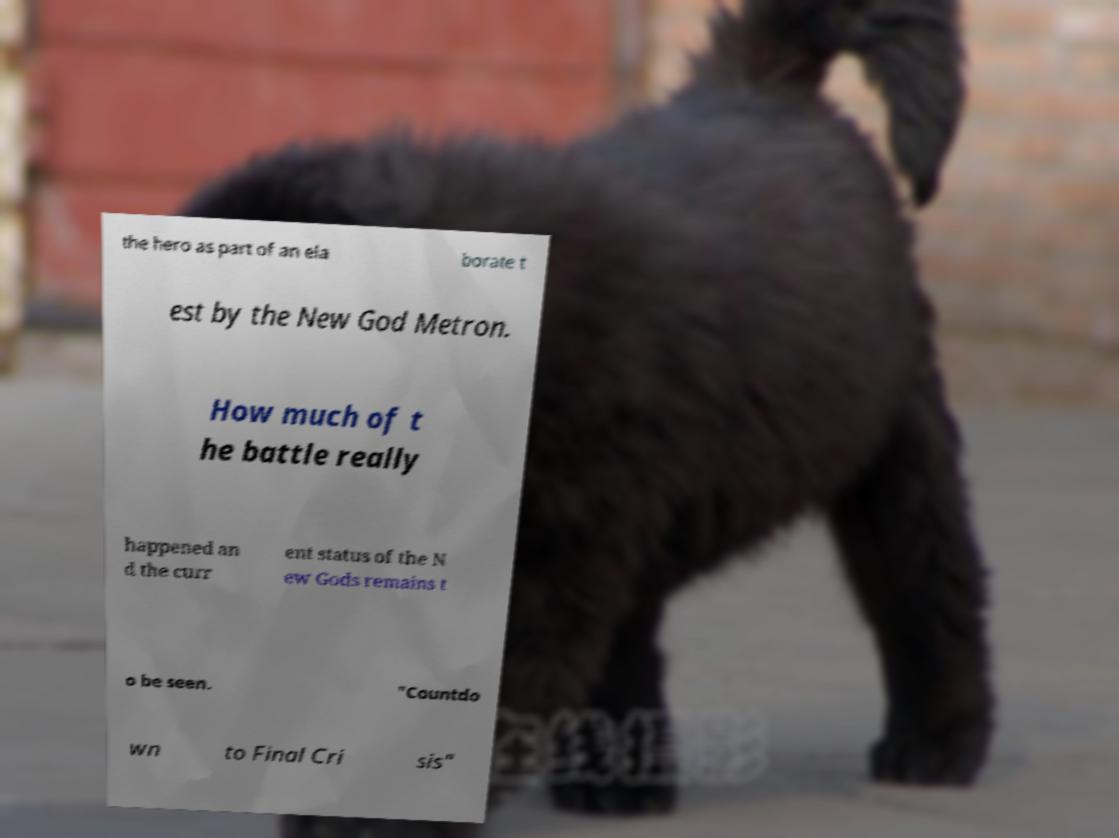Could you assist in decoding the text presented in this image and type it out clearly? the hero as part of an ela borate t est by the New God Metron. How much of t he battle really happened an d the curr ent status of the N ew Gods remains t o be seen. "Countdo wn to Final Cri sis" 